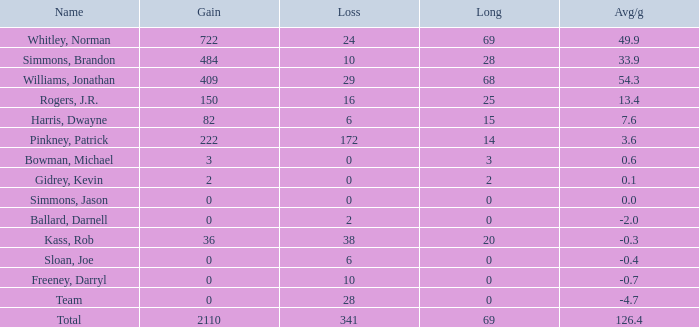What is the minimum long, when name is kass, rob, and when avg/g is below - None. 